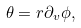<formula> <loc_0><loc_0><loc_500><loc_500>\theta = r \partial _ { v } \phi ,</formula> 